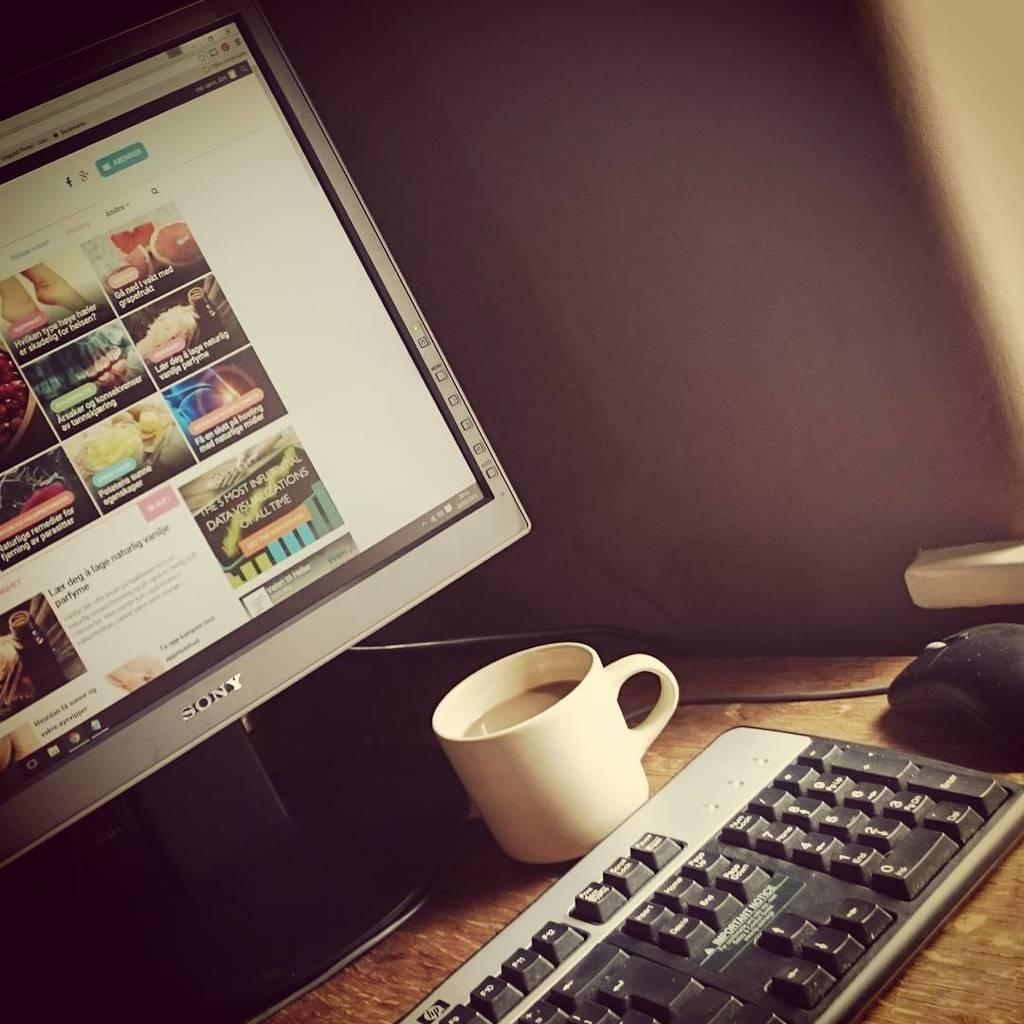What type of electronic device is present in the image? There is a monitor in the image. What other object related to the monitor can be seen in the image? There is a keyboard in the image. What is the purpose of the object that is similar to a small mouse? There is a mouse in the image, which is used for controlling the monitor. What is placed on the table along with the monitor and keyboard? There is a cup on the table in the image. What type of card is being used to create the visual effects in the image? There is no card or visual effects present in the image; it features a monitor, keyboard, mouse, and cup on a table. What type of drug is being used to enhance the performance of the computer in the image? There is no drug present in the image, and the performance of the computer is not affected by any drug. 